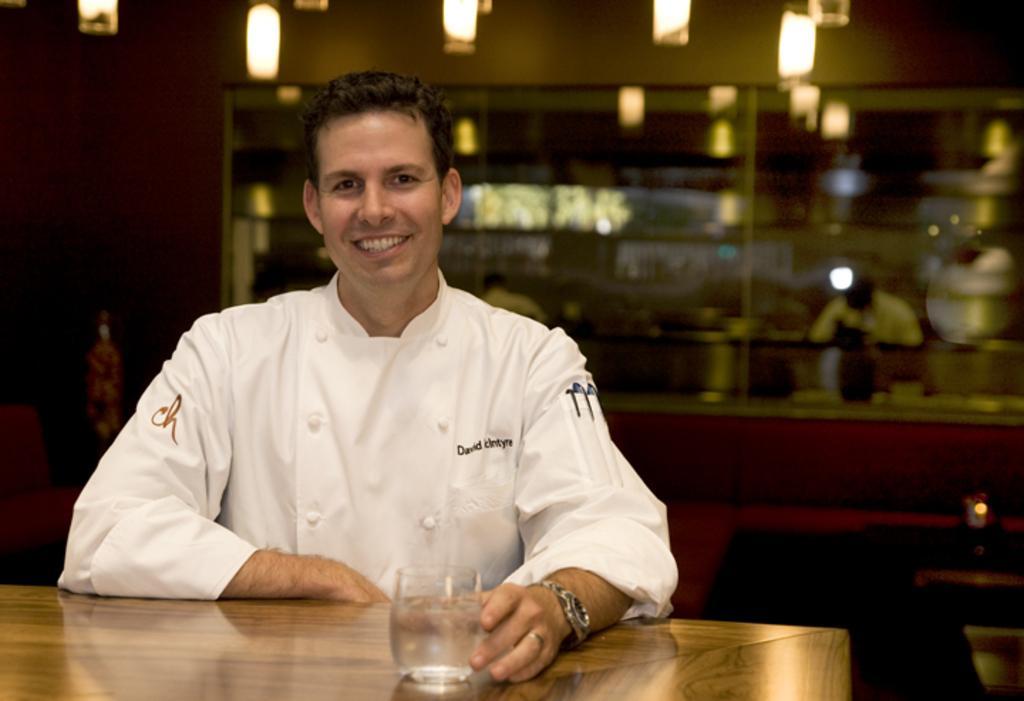Could you give a brief overview of what you see in this image? In this image we can see a person. In the background of the image there are lights, wall, persons and other objects. At the bottom of the image there is the glass on the wooden surface. 